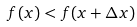Convert formula to latex. <formula><loc_0><loc_0><loc_500><loc_500>f ( x ) < f ( x + \Delta x )</formula> 